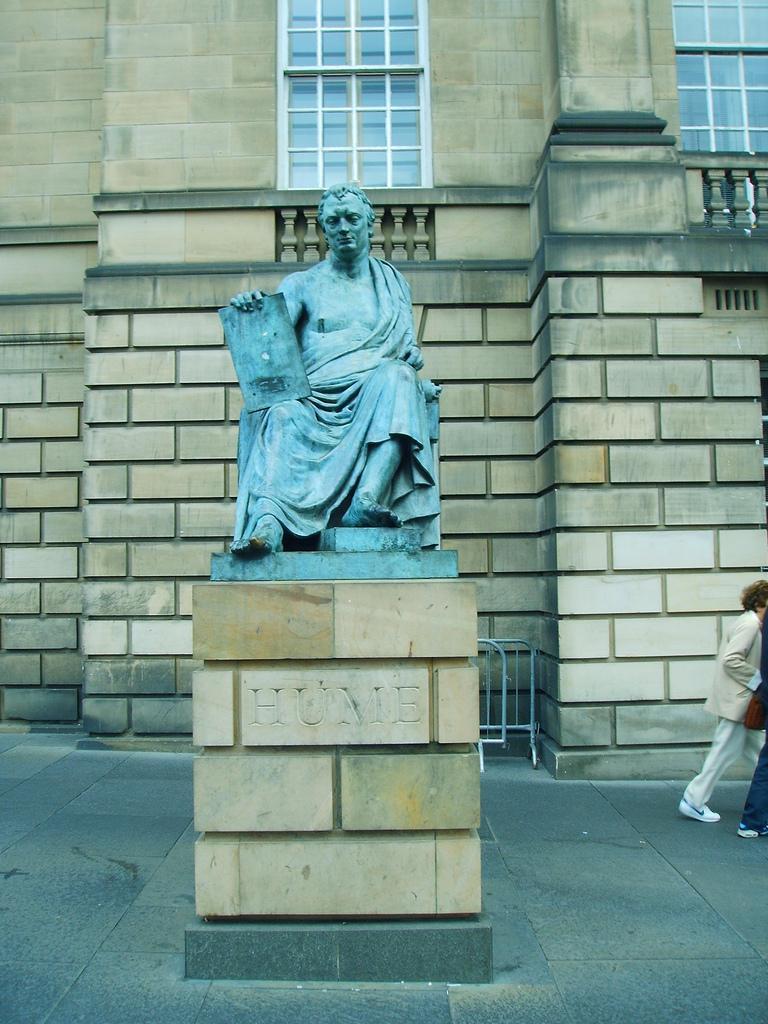Can you describe this image briefly? In this picture I can see a statue of a person sitting and holding an item, there are two persons, barriers, this looks like a building with windows. 